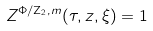Convert formula to latex. <formula><loc_0><loc_0><loc_500><loc_500>Z ^ { \Phi / \mathbf Z _ { 2 } , m } ( \tau , z , \xi ) = 1</formula> 